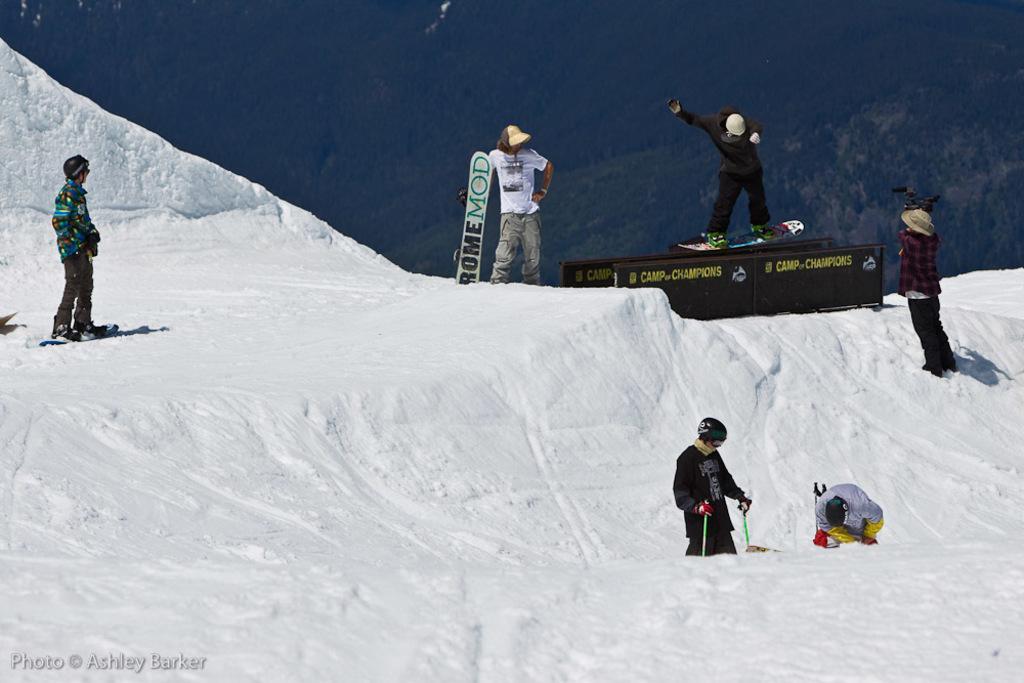Describe this image in one or two sentences. In this image we can see these people are skating on the ice, this person is holding the skateboard and this person is skating on the board. Here we can see this person is holding a video camera in their hands and in the background, we can see trees on the hill. 